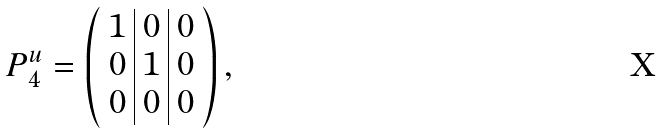<formula> <loc_0><loc_0><loc_500><loc_500>P ^ { u } _ { 4 } = \left ( \begin{array} { c | c | c } 1 & 0 & 0 \\ 0 & 1 & 0 \\ 0 & 0 & 0 \end{array} \right ) ,</formula> 